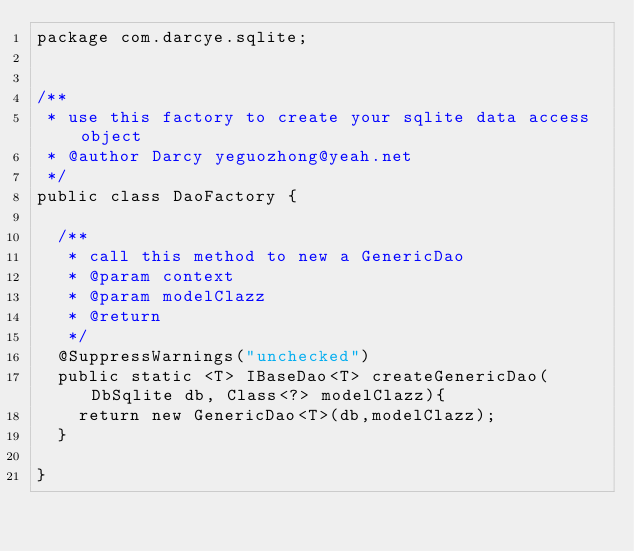Convert code to text. <code><loc_0><loc_0><loc_500><loc_500><_Java_>package com.darcye.sqlite;


/**
 * use this factory to create your sqlite data access object
 * @author Darcy yeguozhong@yeah.net
 */
public class DaoFactory {
	
	/**
	 * call this method to new a GenericDao
	 * @param context
	 * @param modelClazz
	 * @return
	 */
	@SuppressWarnings("unchecked")
	public static <T> IBaseDao<T> createGenericDao(DbSqlite db, Class<?> modelClazz){
		return new GenericDao<T>(db,modelClazz);
	}  

}
</code> 